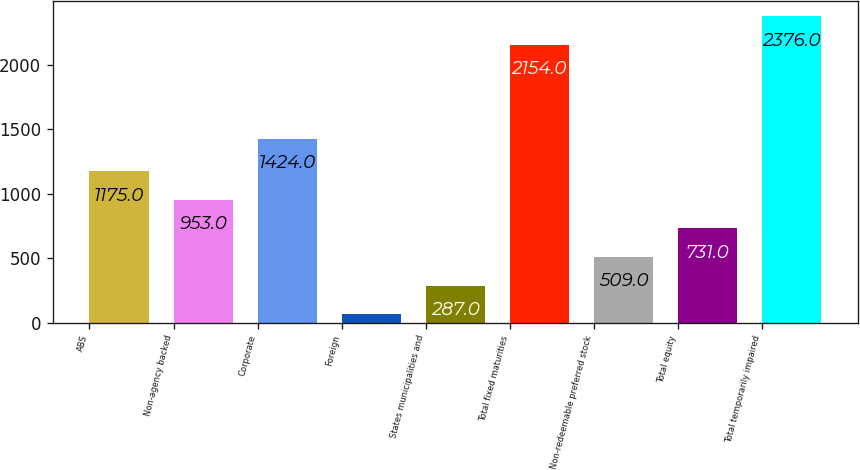<chart> <loc_0><loc_0><loc_500><loc_500><bar_chart><fcel>ABS<fcel>Non-agency backed<fcel>Corporate<fcel>Foreign<fcel>States municipalities and<fcel>Total fixed maturities<fcel>Non-redeemable preferred stock<fcel>Total equity<fcel>Total temporarily impaired<nl><fcel>1175<fcel>953<fcel>1424<fcel>65<fcel>287<fcel>2154<fcel>509<fcel>731<fcel>2376<nl></chart> 